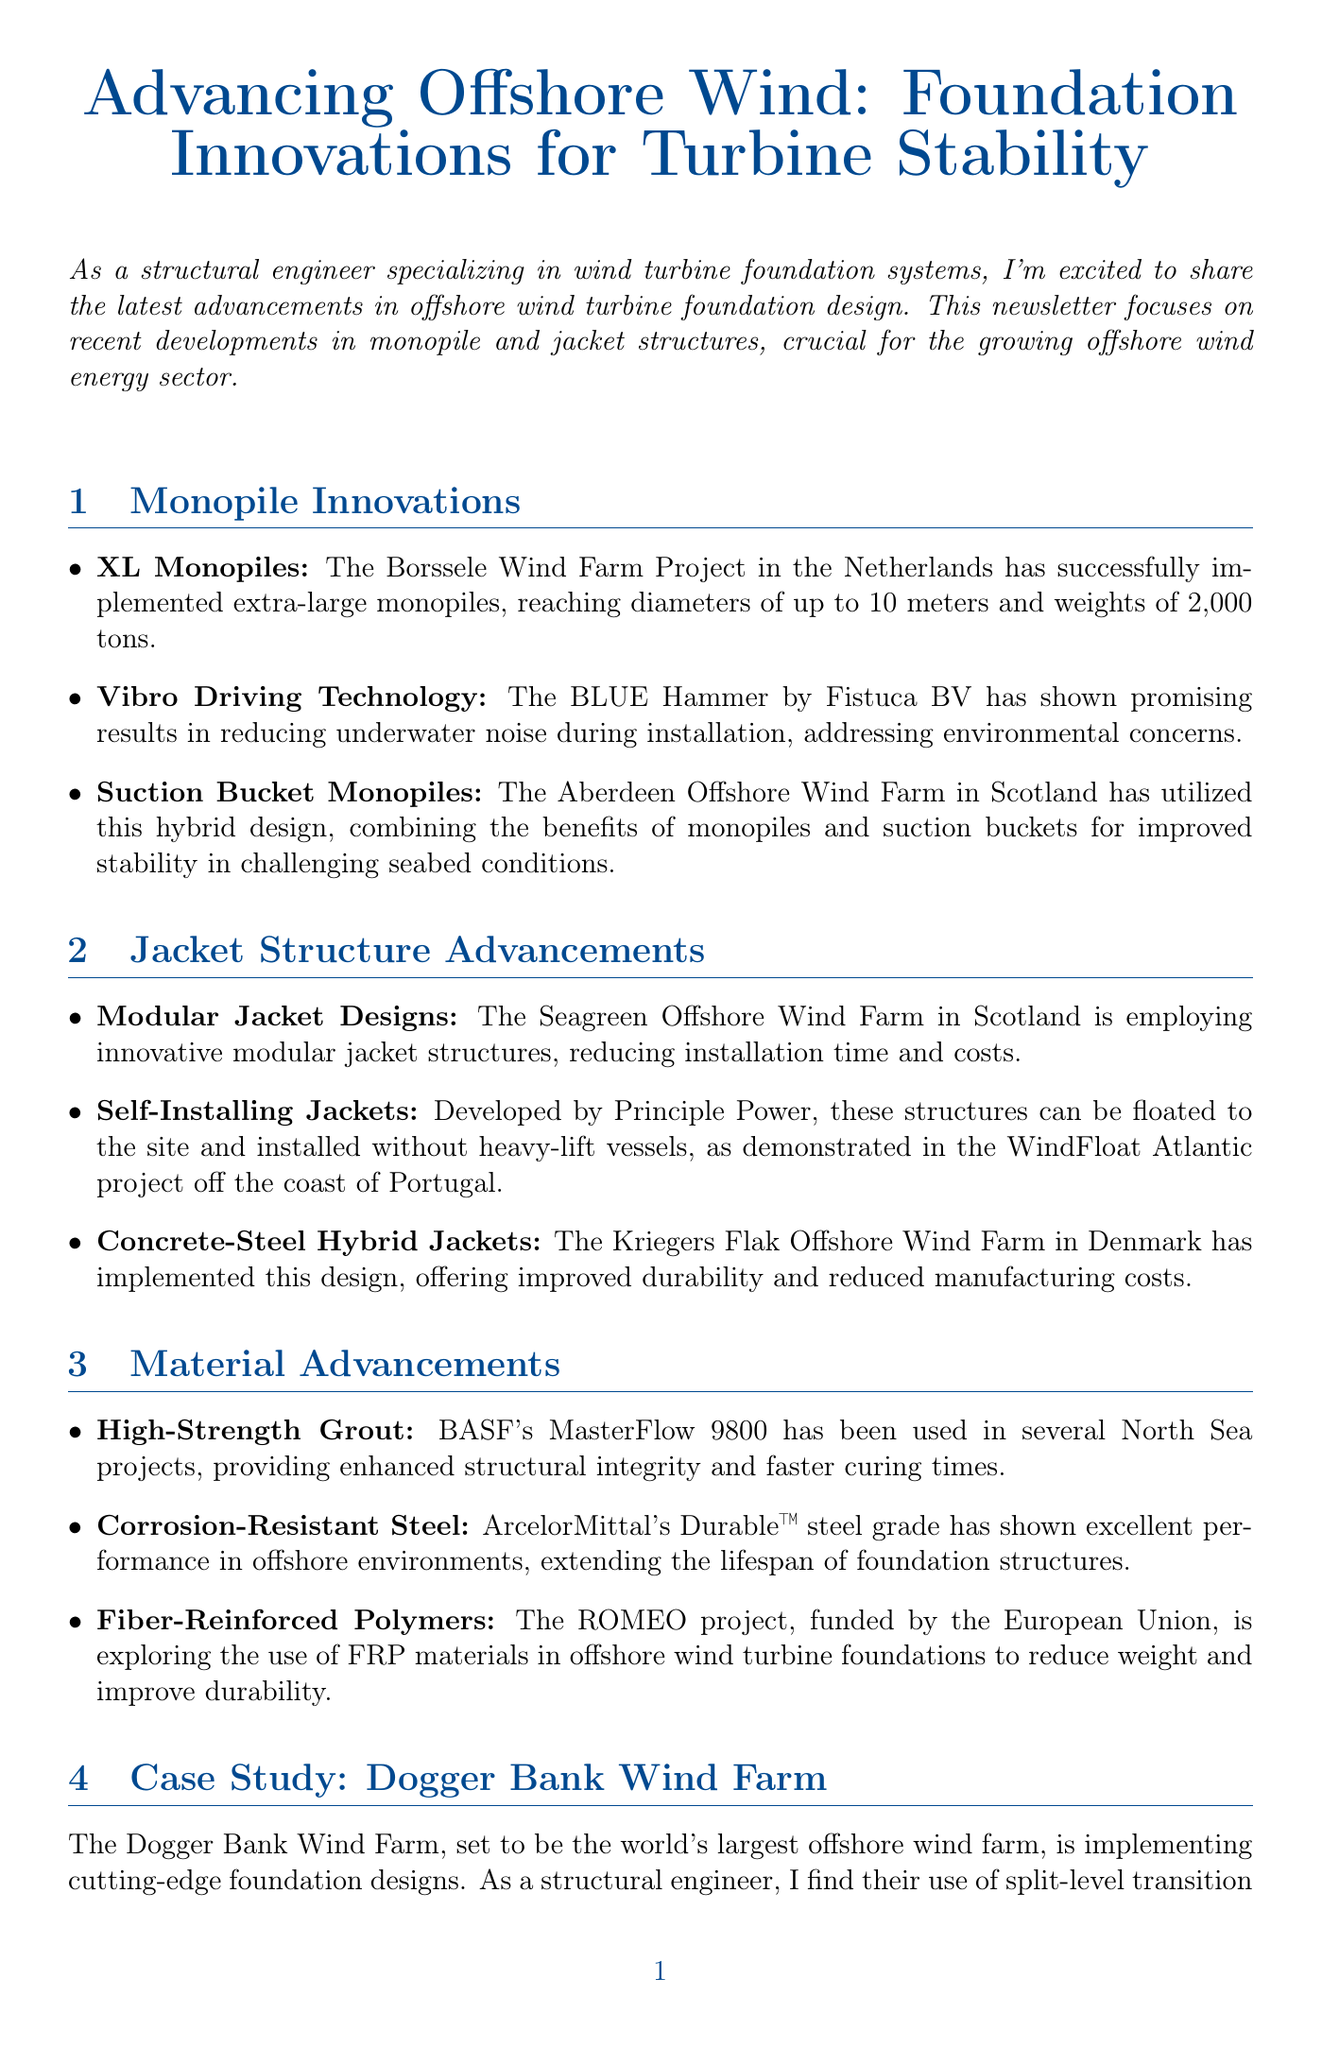What is the diameter of the XL monopiles used in Borssele Wind Farm? The document states that the XL monopiles reach diameters of up to 10 meters.
Answer: 10 meters What innovative technology is used to reduce underwater noise during installation? The BLUE Hammer by Fistuca BV is mentioned as the technology that reduces underwater noise.
Answer: BLUE Hammer Which offshore wind farm utilizes suction bucket monopiles? The Aberdeen Offshore Wind Farm in Scotland is noted for utilizing this hybrid design.
Answer: Aberdeen Offshore Wind Farm What type of designs is being employed in the Seagreen Offshore Wind Farm? The newsletter notes the use of innovative modular jacket structures at the Seagreen Offshore Wind Farm.
Answer: Modular jacket structures What is the name of the high-strength grout mentioned in the newsletter? BASF's MasterFlow 9800 is identified as the high-strength grout used in North Sea projects.
Answer: MasterFlow 9800 What foundation design innovation is highlighted in the Dogger Bank Wind Farm case study? The use of split-level transition pieces is emphasized as a cutting-edge foundation design innovation.
Answer: Split-level transition pieces How many points are listed in the Future Trends section? The document presents four points regarding future trends in offshore wind foundations.
Answer: Four What advanced material is being explored in the ROMEO project? Fiber-Reinforced Polymers (FRP) are explored in the ROMEO project for offshore wind turbine foundations.
Answer: Fiber-Reinforced Polymers Which company developed the self-installing jackets mentioned in the newsletter? Principle Power is mentioned as the developer of self-installing jackets.
Answer: Principle Power 